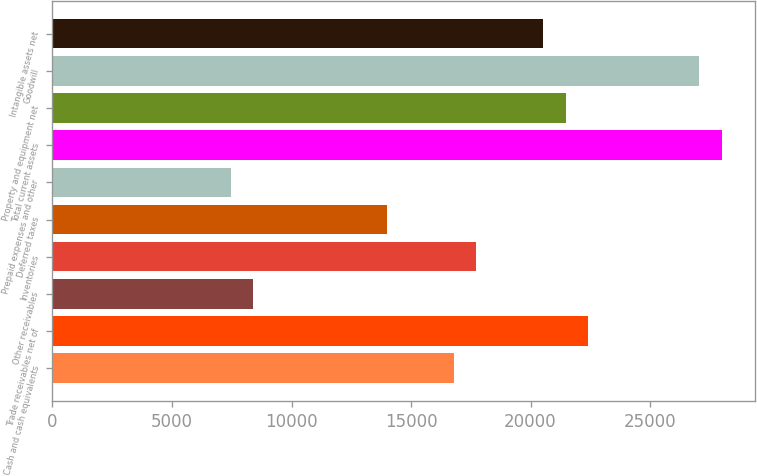Convert chart to OTSL. <chart><loc_0><loc_0><loc_500><loc_500><bar_chart><fcel>Cash and cash equivalents<fcel>Trade receivables net of<fcel>Other receivables<fcel>Inventories<fcel>Deferred taxes<fcel>Prepaid expenses and other<fcel>Total current assets<fcel>Property and equipment net<fcel>Goodwill<fcel>Intangible assets net<nl><fcel>16796.7<fcel>22395.4<fcel>8398.58<fcel>17729.8<fcel>13997.3<fcel>7465.46<fcel>27994.1<fcel>21462.3<fcel>27061<fcel>20529.1<nl></chart> 